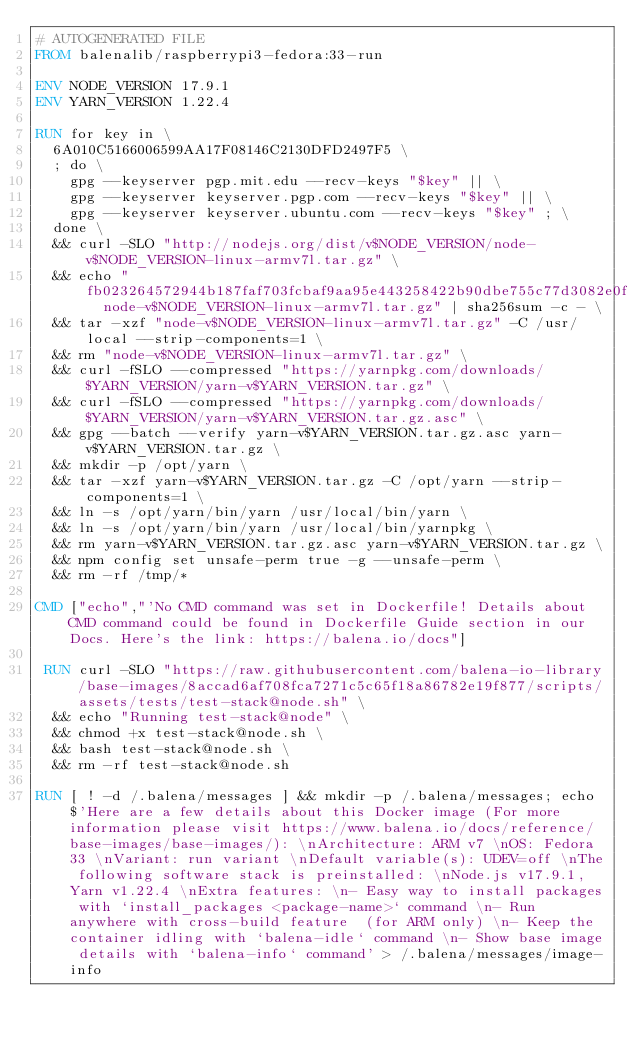Convert code to text. <code><loc_0><loc_0><loc_500><loc_500><_Dockerfile_># AUTOGENERATED FILE
FROM balenalib/raspberrypi3-fedora:33-run

ENV NODE_VERSION 17.9.1
ENV YARN_VERSION 1.22.4

RUN for key in \
	6A010C5166006599AA17F08146C2130DFD2497F5 \
	; do \
		gpg --keyserver pgp.mit.edu --recv-keys "$key" || \
		gpg --keyserver keyserver.pgp.com --recv-keys "$key" || \
		gpg --keyserver keyserver.ubuntu.com --recv-keys "$key" ; \
	done \
	&& curl -SLO "http://nodejs.org/dist/v$NODE_VERSION/node-v$NODE_VERSION-linux-armv7l.tar.gz" \
	&& echo "fb023264572944b187faf703fcbaf9aa95e443258422b90dbe755c77d3082e0f  node-v$NODE_VERSION-linux-armv7l.tar.gz" | sha256sum -c - \
	&& tar -xzf "node-v$NODE_VERSION-linux-armv7l.tar.gz" -C /usr/local --strip-components=1 \
	&& rm "node-v$NODE_VERSION-linux-armv7l.tar.gz" \
	&& curl -fSLO --compressed "https://yarnpkg.com/downloads/$YARN_VERSION/yarn-v$YARN_VERSION.tar.gz" \
	&& curl -fSLO --compressed "https://yarnpkg.com/downloads/$YARN_VERSION/yarn-v$YARN_VERSION.tar.gz.asc" \
	&& gpg --batch --verify yarn-v$YARN_VERSION.tar.gz.asc yarn-v$YARN_VERSION.tar.gz \
	&& mkdir -p /opt/yarn \
	&& tar -xzf yarn-v$YARN_VERSION.tar.gz -C /opt/yarn --strip-components=1 \
	&& ln -s /opt/yarn/bin/yarn /usr/local/bin/yarn \
	&& ln -s /opt/yarn/bin/yarn /usr/local/bin/yarnpkg \
	&& rm yarn-v$YARN_VERSION.tar.gz.asc yarn-v$YARN_VERSION.tar.gz \
	&& npm config set unsafe-perm true -g --unsafe-perm \
	&& rm -rf /tmp/*

CMD ["echo","'No CMD command was set in Dockerfile! Details about CMD command could be found in Dockerfile Guide section in our Docs. Here's the link: https://balena.io/docs"]

 RUN curl -SLO "https://raw.githubusercontent.com/balena-io-library/base-images/8accad6af708fca7271c5c65f18a86782e19f877/scripts/assets/tests/test-stack@node.sh" \
  && echo "Running test-stack@node" \
  && chmod +x test-stack@node.sh \
  && bash test-stack@node.sh \
  && rm -rf test-stack@node.sh 

RUN [ ! -d /.balena/messages ] && mkdir -p /.balena/messages; echo $'Here are a few details about this Docker image (For more information please visit https://www.balena.io/docs/reference/base-images/base-images/): \nArchitecture: ARM v7 \nOS: Fedora 33 \nVariant: run variant \nDefault variable(s): UDEV=off \nThe following software stack is preinstalled: \nNode.js v17.9.1, Yarn v1.22.4 \nExtra features: \n- Easy way to install packages with `install_packages <package-name>` command \n- Run anywhere with cross-build feature  (for ARM only) \n- Keep the container idling with `balena-idle` command \n- Show base image details with `balena-info` command' > /.balena/messages/image-info</code> 